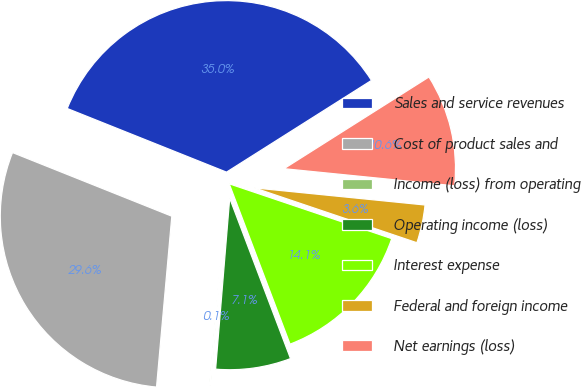Convert chart to OTSL. <chart><loc_0><loc_0><loc_500><loc_500><pie_chart><fcel>Sales and service revenues<fcel>Cost of product sales and<fcel>Income (loss) from operating<fcel>Operating income (loss)<fcel>Interest expense<fcel>Federal and foreign income<fcel>Net earnings (loss)<nl><fcel>34.97%<fcel>29.63%<fcel>0.11%<fcel>7.08%<fcel>14.05%<fcel>3.59%<fcel>10.57%<nl></chart> 